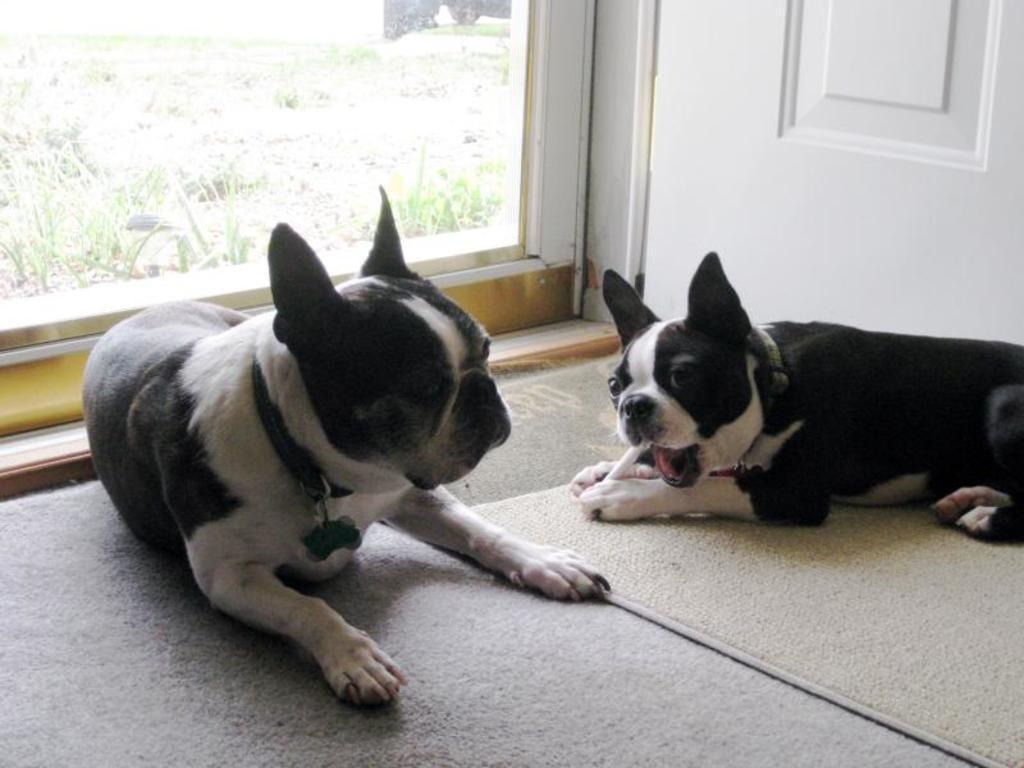Could you give a brief overview of what you see in this image? There are two dogs on the floor. And one dog is on a carpet. In the back there's a wall and a glass window. 